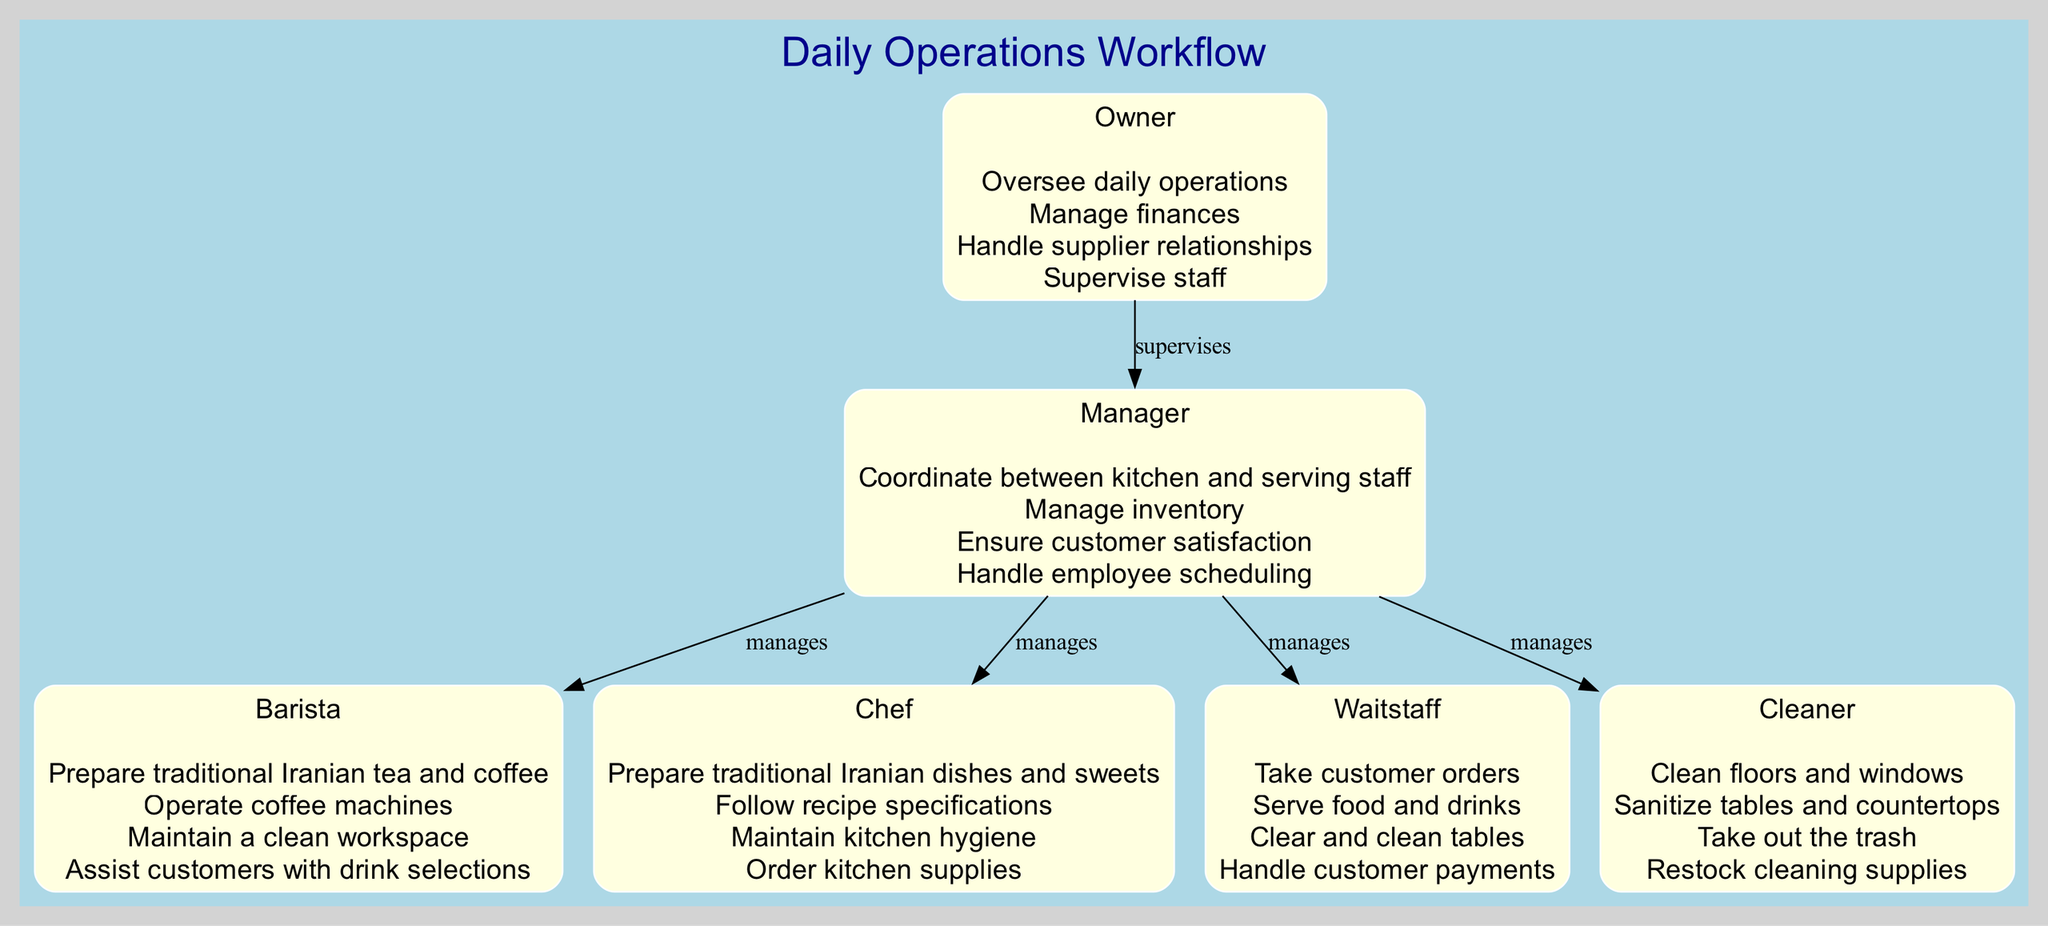What is the total number of roles in the diagram? The diagram displays six distinct roles as indicated by six separate nodes: Owner, Manager, Barista, Chef, Waitstaff, and Cleaner.
Answer: 6 Who supervises the Manager? The diagram shows an edge pointing from the Owner to the Manager, indicating the Owner's supervisory role over the Manager.
Answer: Owner Which role is responsible for preparing traditional Iranian dishes? The Chef role includes responsibilities that specifically mention "Prepare traditional Iranian dishes and sweets," clearly pointing to the Chef as responsible for this task.
Answer: Chef How many edges are connected to the Manager? The Manager node has five edges emanating from it, connecting to Barista, Chef, Waitstaff, and Cleaner. This reflects that the Manager manages multiple staff roles.
Answer: 5 What are the main responsibilities of the Barista? The diagram details the Barista's responsibilities, listing them as "Prepare traditional Iranian tea and coffee, Operate coffee machines, Maintain a clean workspace, and Assist customers with drink selections," providing a full account of the Barista's tasks.
Answer: Prepare traditional Iranian tea and coffee, Operate coffee machines, Maintain a clean workspace, Assist customers with drink selections Which role is directly linked to handling customer satisfaction? The Manager role is explicitly stated to "Ensure customer satisfaction," establishing this as the responsibility of the Manager in the diagram.
Answer: Manager What type of diagram is this? The diagram is structured as a Block Diagram, which represents roles and their responsibilities in a workflow format with nodes and directed edges.
Answer: Block Diagram Explain the relationship between the Manager and the Chef. The diagram illustrates a direct connection (edge) labeled "manages" from the Manager to the Chef, indicating that the Manager is in charge of the Chef's operations and coordination within the workflow.
Answer: Manages Which role is responsible for cleaning and sanitizing? The Cleaner role includes specific responsibilities such as "Clean floors and windows, Sanitize tables and countertops," designating the Cleaner as the role tasked with cleanliness and sanitation in the café.
Answer: Cleaner 